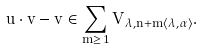Convert formula to latex. <formula><loc_0><loc_0><loc_500><loc_500>u \cdot v - v \in \sum _ { m \geq 1 } V _ { \lambda , n + m \langle \lambda , \alpha \rangle } .</formula> 